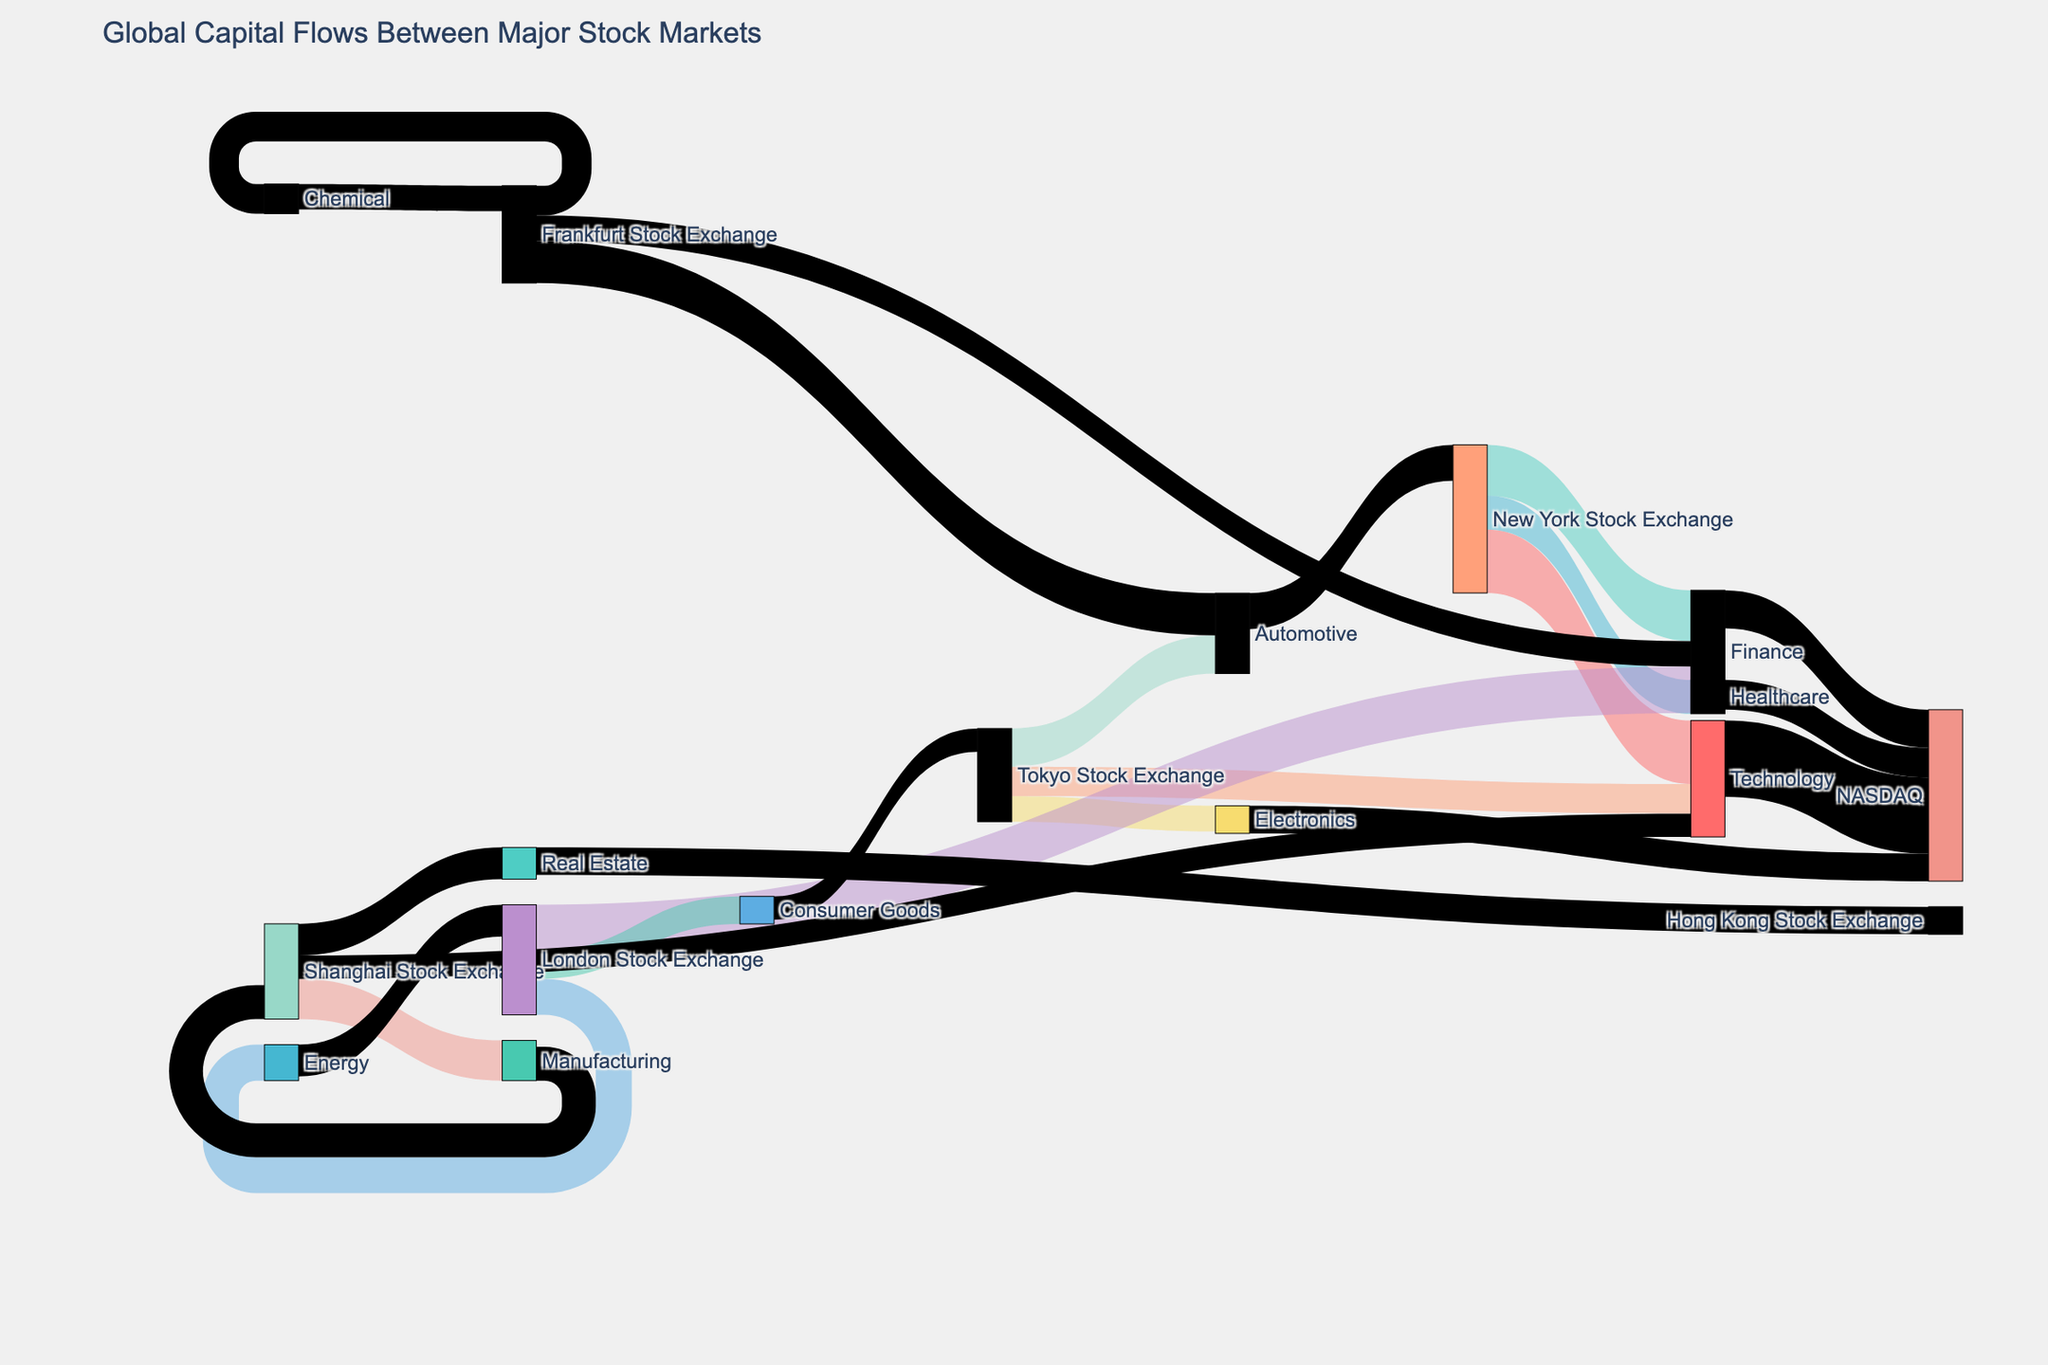What is the title of the figure? The title is typically displayed prominently at the top of the figure, and it sets the context for the entire plot.
Answer: Global Capital Flows Between Major Stock Markets How many stock markets are shown as sources? By counting the unique names listed under the source column in the diagram, we can determine the number of stock markets.
Answer: 5 Which industry sector receives the highest capital flow from the New York Stock Exchange? The largest number associated with a flow coming from the New York Stock Exchange to an industry sector indicates the highest capital flow.
Answer: Technology How much total capital flows into NASDAQ from different industry sectors? By summing the values of all flows that target NASDAQ, we can find the total capital flow into it.
Answer: 405 Compare the capital flows into the Finance sector from the New York Stock Exchange and the London Stock Exchange. Which one is higher? We compare the values for the Finance sector from both stock exchanges shown in the diagram.
Answer: New York Stock Exchange Which stock market sends the most capital to the Automotive sector? By comparing the values of capital flows from the different stock markets to the Automotive sector, we identify the highest value.
Answer: Tokyo Stock Exchange How does the capital flow value from the Frankfurt Stock Exchange to Finance compare with that from the New York Stock Exchange? The diagram shows that the capital flow associated with the New York Stock Exchange is higher than the one from the Frankfurt Stock Exchange.
Answer: New York Stock Exchange What is the source for the majority of the Real Estate capital flow? By tracing the links to the Real Estate sector, we look for the stock market with the highest corresponding value.
Answer: Shanghai Stock Exchange Which industry sector shows a significant flow of capital from both New York Stock Exchange and London Stock Exchange? By looking at the links from both these stock markets to industry sectors, we identify the sector that has substantial values from both.
Answer: Finance 